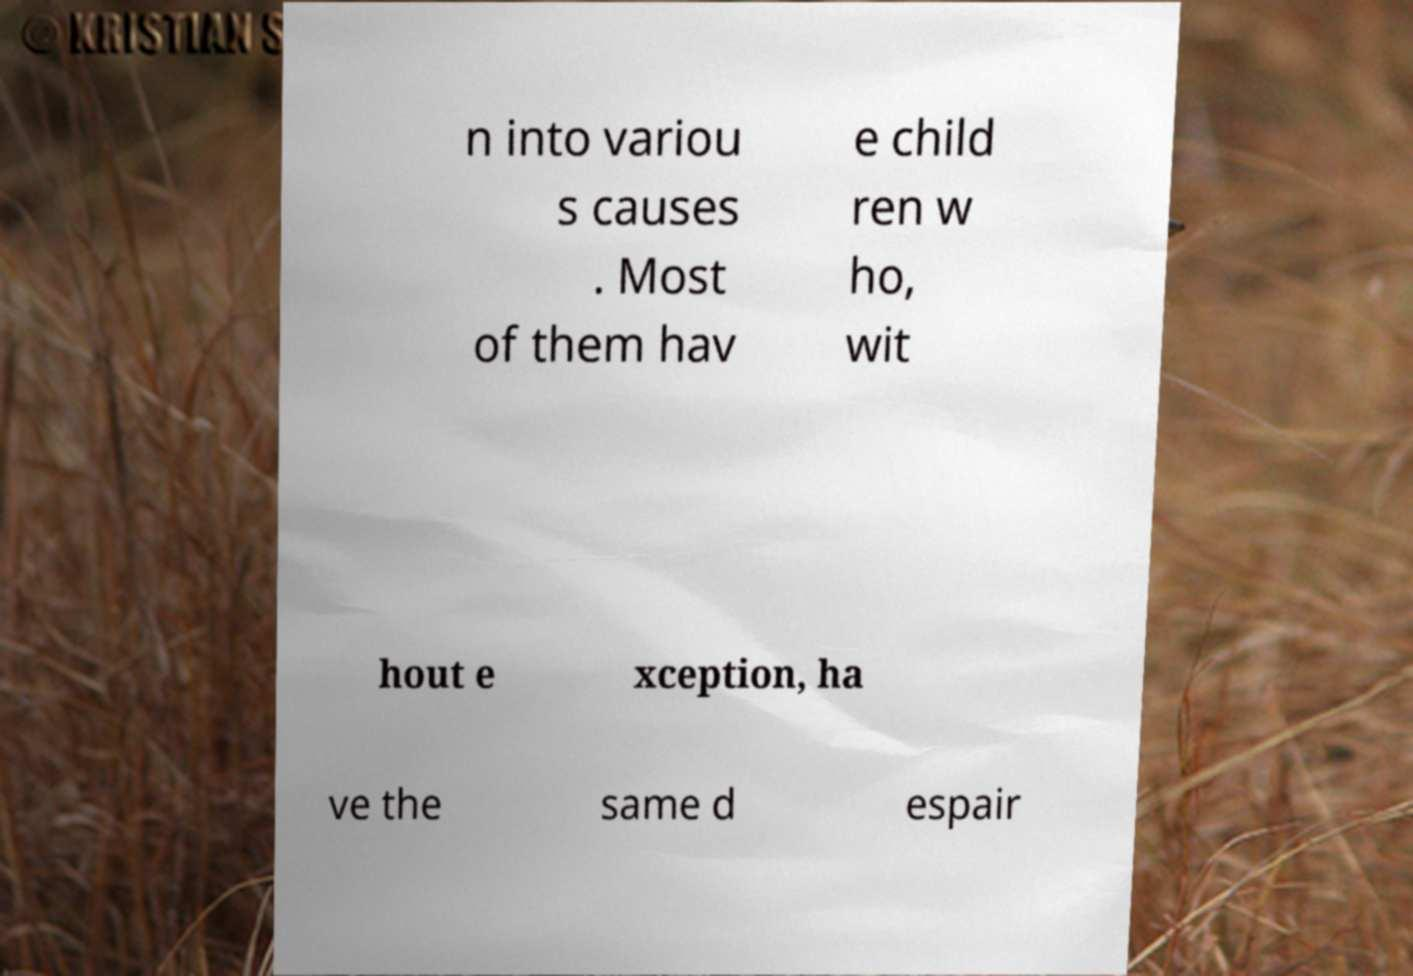What messages or text are displayed in this image? I need them in a readable, typed format. n into variou s causes . Most of them hav e child ren w ho, wit hout e xception, ha ve the same d espair 